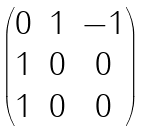<formula> <loc_0><loc_0><loc_500><loc_500>\begin{pmatrix} 0 & 1 & - 1 \\ 1 & 0 & 0 \\ 1 & 0 & 0 \end{pmatrix}</formula> 